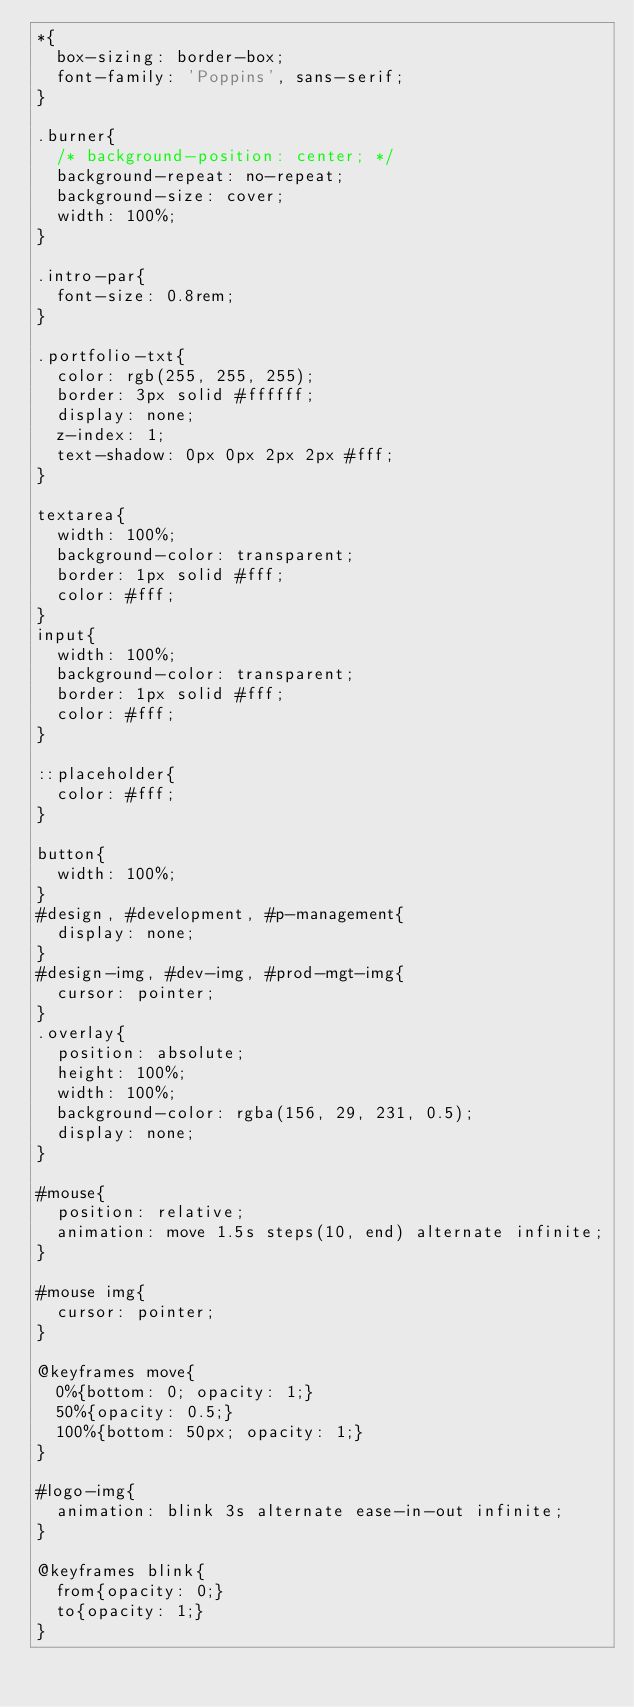<code> <loc_0><loc_0><loc_500><loc_500><_CSS_>*{
  box-sizing: border-box;
  font-family: 'Poppins', sans-serif;
}

.burner{
  /* background-position: center; */
  background-repeat: no-repeat;
  background-size: cover;
  width: 100%;
}

.intro-par{
  font-size: 0.8rem;
}

.portfolio-txt{
  color: rgb(255, 255, 255);
  border: 3px solid #ffffff;
  display: none;
  z-index: 1;
  text-shadow: 0px 0px 2px 2px #fff;
}

textarea{
  width: 100%;
  background-color: transparent;
  border: 1px solid #fff;
  color: #fff;
}
input{
  width: 100%;
  background-color: transparent;
  border: 1px solid #fff;
  color: #fff;
}

::placeholder{
  color: #fff;
}

button{
  width: 100%;
}
#design, #development, #p-management{
  display: none;
}
#design-img, #dev-img, #prod-mgt-img{
  cursor: pointer;
}
.overlay{
  position: absolute;
  height: 100%;
  width: 100%;
  background-color: rgba(156, 29, 231, 0.5);
  display: none;
}

#mouse{
  position: relative;
  animation: move 1.5s steps(10, end) alternate infinite;
}

#mouse img{
  cursor: pointer;
}

@keyframes move{
  0%{bottom: 0; opacity: 1;}
  50%{opacity: 0.5;}
  100%{bottom: 50px; opacity: 1;}
}

#logo-img{
  animation: blink 3s alternate ease-in-out infinite;
}

@keyframes blink{
  from{opacity: 0;}
  to{opacity: 1;}
}</code> 